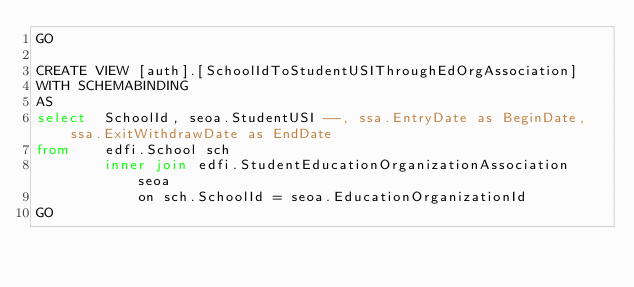<code> <loc_0><loc_0><loc_500><loc_500><_SQL_>GO

CREATE VIEW [auth].[SchoolIdToStudentUSIThroughEdOrgAssociation]
WITH SCHEMABINDING
AS
select	SchoolId, seoa.StudentUSI --, ssa.EntryDate as BeginDate, ssa.ExitWithdrawDate as EndDate
from	edfi.School sch
		inner join edfi.StudentEducationOrganizationAssociation seoa
			on sch.SchoolId = seoa.EducationOrganizationId
GO
</code> 